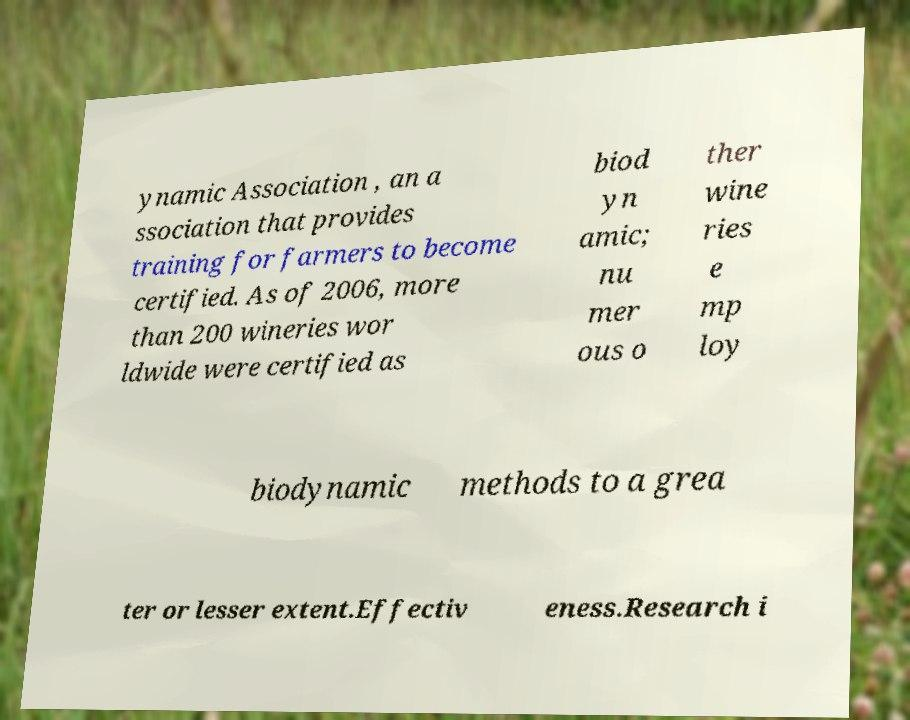I need the written content from this picture converted into text. Can you do that? ynamic Association , an a ssociation that provides training for farmers to become certified. As of 2006, more than 200 wineries wor ldwide were certified as biod yn amic; nu mer ous o ther wine ries e mp loy biodynamic methods to a grea ter or lesser extent.Effectiv eness.Research i 